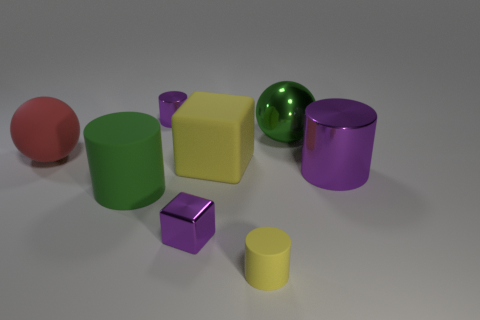Add 1 small rubber cylinders. How many objects exist? 9 Subtract all metallic cubes. Subtract all purple rubber blocks. How many objects are left? 7 Add 7 rubber cylinders. How many rubber cylinders are left? 9 Add 1 gray cylinders. How many gray cylinders exist? 1 Subtract 0 cyan cubes. How many objects are left? 8 Subtract all spheres. How many objects are left? 6 Subtract all green cylinders. Subtract all gray spheres. How many cylinders are left? 3 